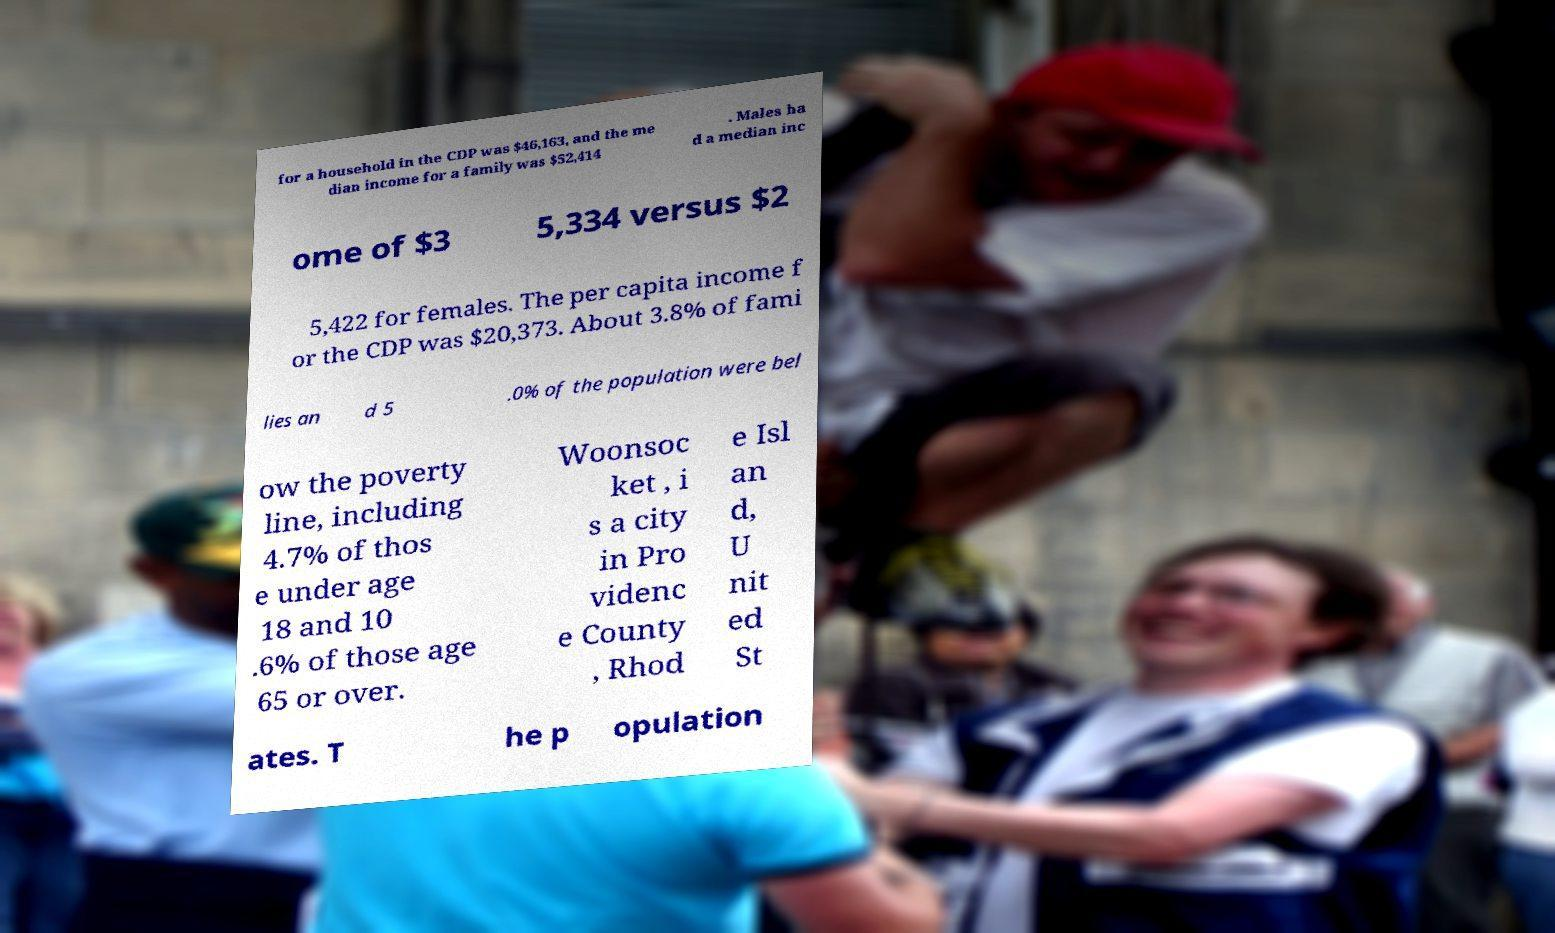Can you read and provide the text displayed in the image?This photo seems to have some interesting text. Can you extract and type it out for me? for a household in the CDP was $46,163, and the me dian income for a family was $52,414 . Males ha d a median inc ome of $3 5,334 versus $2 5,422 for females. The per capita income f or the CDP was $20,373. About 3.8% of fami lies an d 5 .0% of the population were bel ow the poverty line, including 4.7% of thos e under age 18 and 10 .6% of those age 65 or over. Woonsoc ket , i s a city in Pro videnc e County , Rhod e Isl an d, U nit ed St ates. T he p opulation 